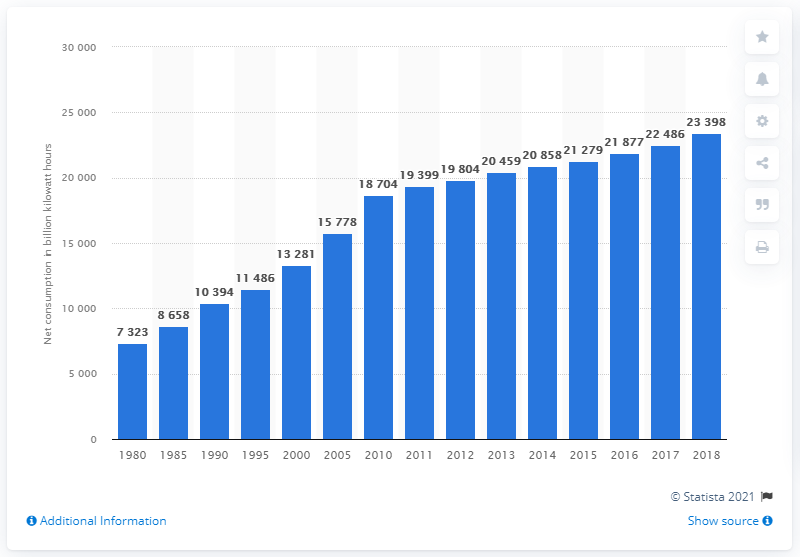What factors can explain the steep rise in global power consumption shown in the chart? The steep rise in global power consumption depicted in the chart can be explained by multiple factors, including rapid industrialization in emerging economies, an increase in the global population, and the widespread adoption of electrical appliances and digital technology. Additionally, economic expansion across the world has led to greater demand for energy in the industrial and service sectors. 